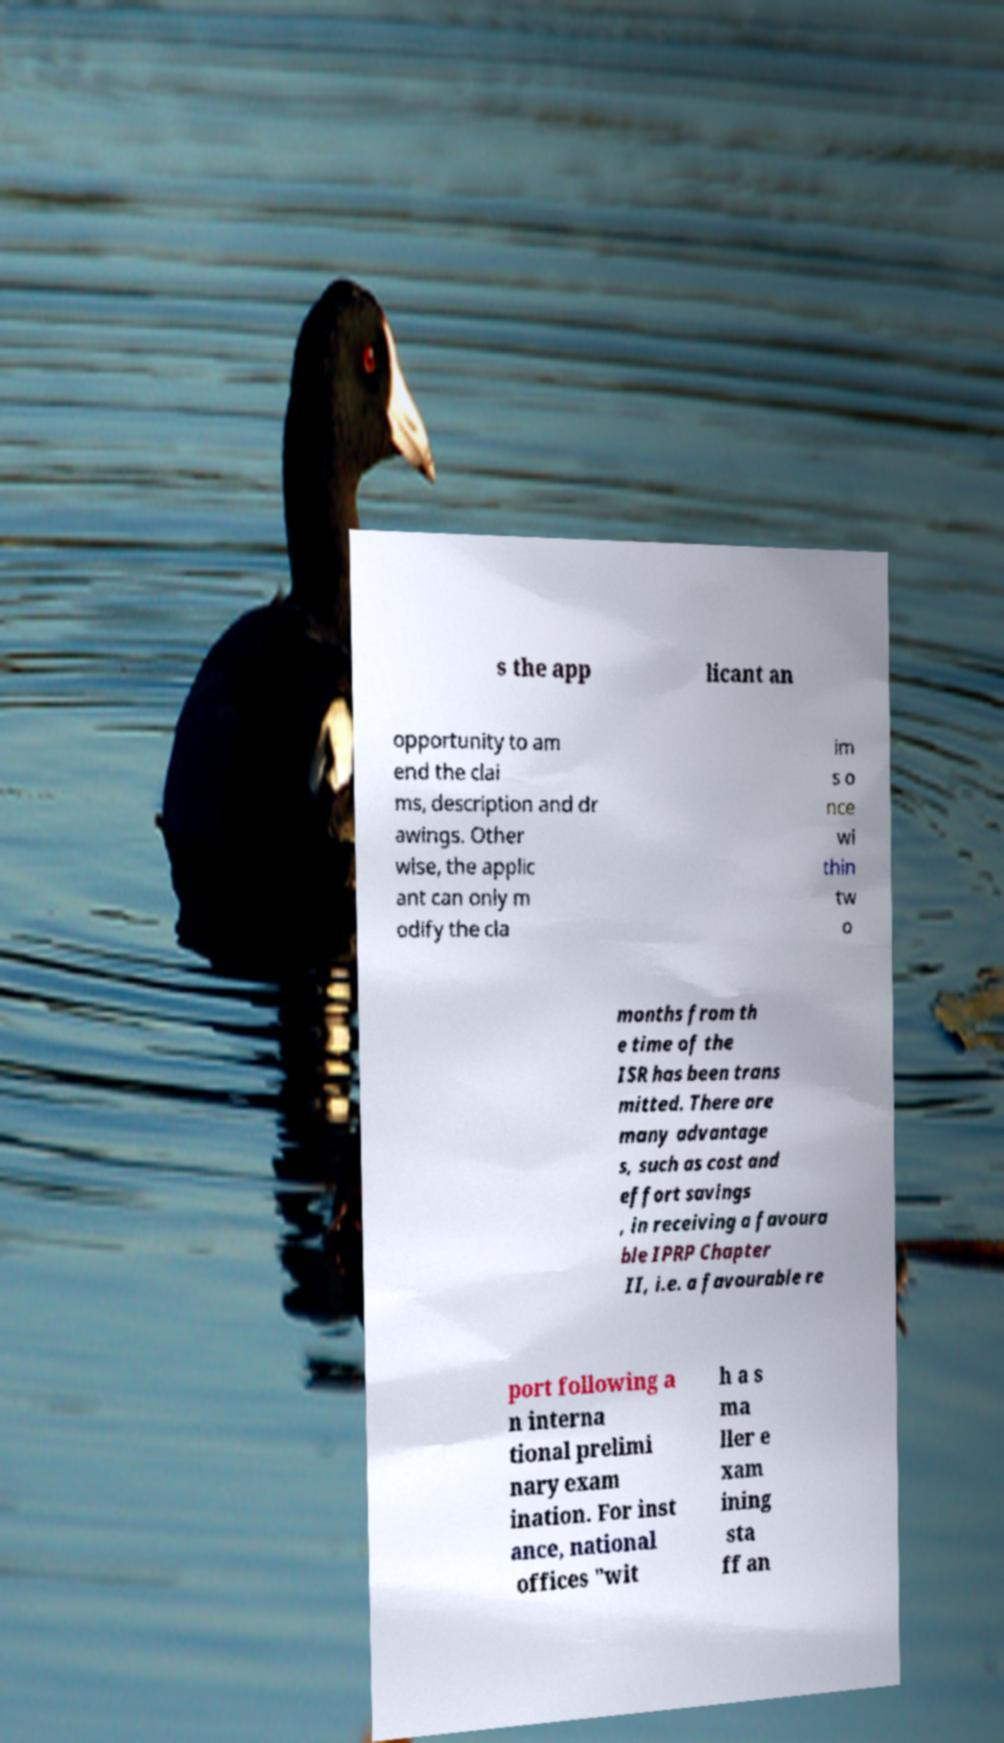Can you read and provide the text displayed in the image?This photo seems to have some interesting text. Can you extract and type it out for me? s the app licant an opportunity to am end the clai ms, description and dr awings. Other wise, the applic ant can only m odify the cla im s o nce wi thin tw o months from th e time of the ISR has been trans mitted. There are many advantage s, such as cost and effort savings , in receiving a favoura ble IPRP Chapter II, i.e. a favourable re port following a n interna tional prelimi nary exam ination. For inst ance, national offices "wit h a s ma ller e xam ining sta ff an 